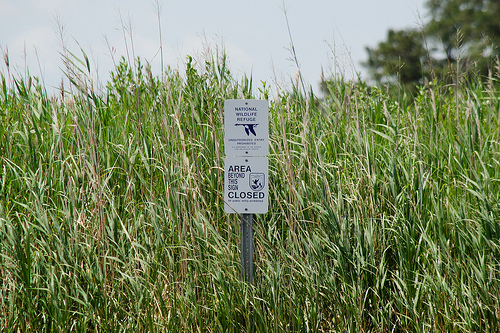<image>
Is there a sign on the grass? Yes. Looking at the image, I can see the sign is positioned on top of the grass, with the grass providing support. 